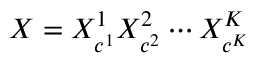<formula> <loc_0><loc_0><loc_500><loc_500>X = X _ { c ^ { 1 } } ^ { 1 } X _ { c ^ { 2 } } ^ { 2 } \cdots X _ { c ^ { K } } ^ { K }</formula> 